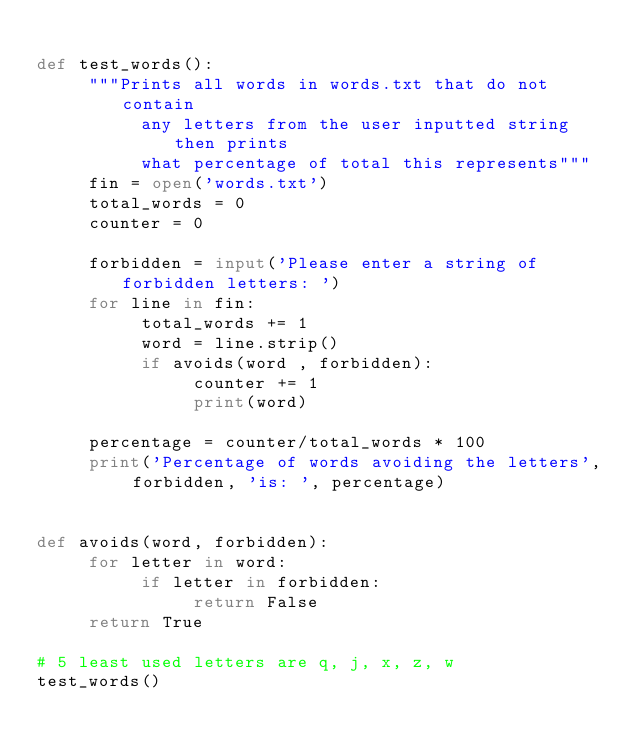<code> <loc_0><loc_0><loc_500><loc_500><_Python_>
def test_words():
     """Prints all words in words.txt that do not contain
          any letters from the user inputted string then prints
          what percentage of total this represents"""
     fin = open('words.txt')
     total_words = 0
     counter = 0

     forbidden = input('Please enter a string of forbidden letters: ')
     for line in fin:
          total_words += 1
          word = line.strip()
          if avoids(word , forbidden):
               counter += 1
               print(word)

     percentage = counter/total_words * 100
     print('Percentage of words avoiding the letters', forbidden, 'is: ', percentage)
     

def avoids(word, forbidden):
     for letter in word:
          if letter in forbidden:
               return False
     return True

# 5 least used letters are q, j, x, z, w
test_words()
          





</code> 